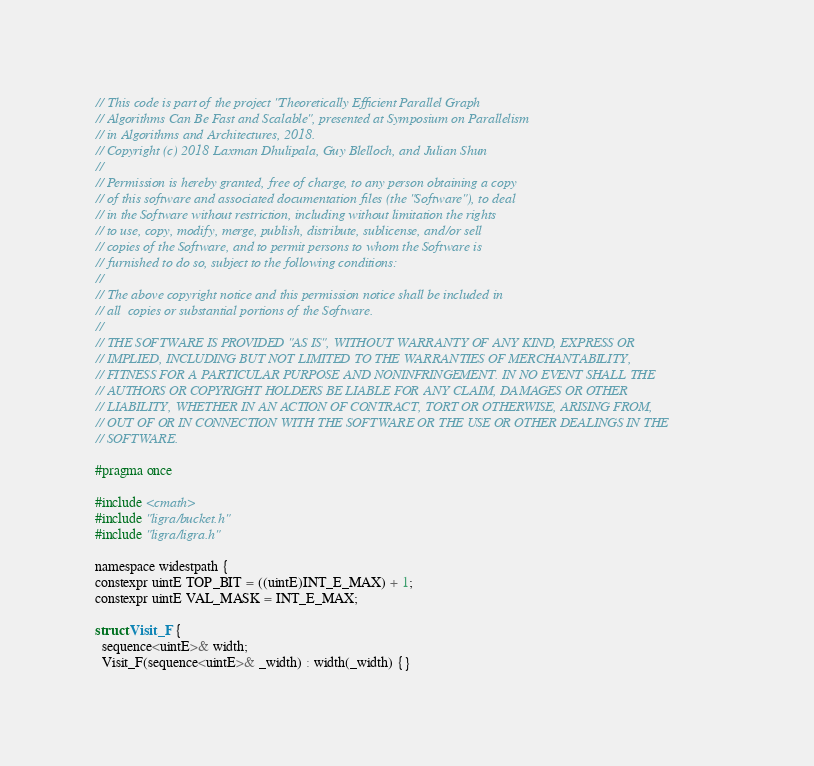<code> <loc_0><loc_0><loc_500><loc_500><_C_>// This code is part of the project "Theoretically Efficient Parallel Graph
// Algorithms Can Be Fast and Scalable", presented at Symposium on Parallelism
// in Algorithms and Architectures, 2018.
// Copyright (c) 2018 Laxman Dhulipala, Guy Blelloch, and Julian Shun
//
// Permission is hereby granted, free of charge, to any person obtaining a copy
// of this software and associated documentation files (the "Software"), to deal
// in the Software without restriction, including without limitation the rights
// to use, copy, modify, merge, publish, distribute, sublicense, and/or sell
// copies of the Software, and to permit persons to whom the Software is
// furnished to do so, subject to the following conditions:
//
// The above copyright notice and this permission notice shall be included in
// all  copies or substantial portions of the Software.
//
// THE SOFTWARE IS PROVIDED "AS IS", WITHOUT WARRANTY OF ANY KIND, EXPRESS OR
// IMPLIED, INCLUDING BUT NOT LIMITED TO THE WARRANTIES OF MERCHANTABILITY,
// FITNESS FOR A PARTICULAR PURPOSE AND NONINFRINGEMENT. IN NO EVENT SHALL THE
// AUTHORS OR COPYRIGHT HOLDERS BE LIABLE FOR ANY CLAIM, DAMAGES OR OTHER
// LIABILITY, WHETHER IN AN ACTION OF CONTRACT, TORT OR OTHERWISE, ARISING FROM,
// OUT OF OR IN CONNECTION WITH THE SOFTWARE OR THE USE OR OTHER DEALINGS IN THE
// SOFTWARE.

#pragma once

#include <cmath>
#include "ligra/bucket.h"
#include "ligra/ligra.h"

namespace widestpath {
constexpr uintE TOP_BIT = ((uintE)INT_E_MAX) + 1;
constexpr uintE VAL_MASK = INT_E_MAX;

struct Visit_F {
  sequence<uintE>& width;
  Visit_F(sequence<uintE>& _width) : width(_width) {}
</code> 